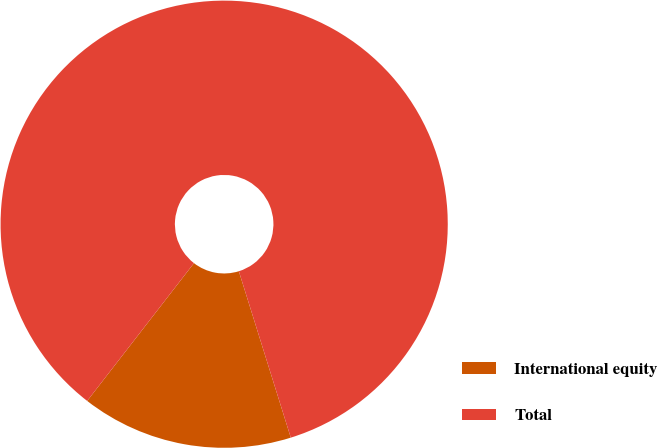<chart> <loc_0><loc_0><loc_500><loc_500><pie_chart><fcel>International equity<fcel>Total<nl><fcel>15.31%<fcel>84.69%<nl></chart> 